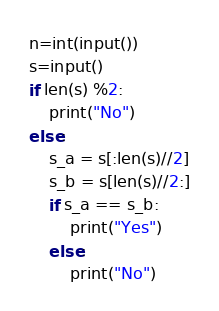<code> <loc_0><loc_0><loc_500><loc_500><_Python_>n=int(input())
s=input()
if len(s) %2:
    print("No")
else:
    s_a = s[:len(s)//2]
    s_b = s[len(s)//2:]
    if s_a == s_b:
        print("Yes")
    else:
        print("No")</code> 